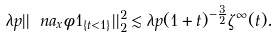Convert formula to latex. <formula><loc_0><loc_0><loc_500><loc_500>\lambda p | | \ n a _ { x } \phi 1 _ { \{ t < 1 \} } | | ^ { 2 } _ { 2 } \lesssim \lambda p ( 1 + t ) ^ { - \frac { 3 } { 2 } } \zeta ^ { \infty } ( t ) .</formula> 